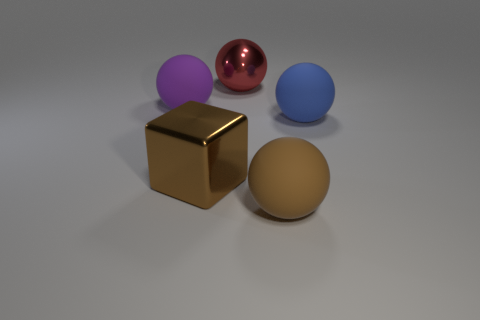Is the object that is left of the brown metallic cube made of the same material as the red sphere?
Ensure brevity in your answer.  No. What number of big matte objects are both behind the big brown metallic block and to the left of the blue ball?
Make the answer very short. 1. There is a shiny thing behind the matte object behind the large blue matte ball; how big is it?
Provide a succinct answer. Large. Is there any other thing that has the same material as the large cube?
Ensure brevity in your answer.  Yes. Are there more small green things than large blue objects?
Ensure brevity in your answer.  No. There is a metal thing to the left of the large shiny ball; is its color the same as the matte sphere to the left of the metal ball?
Keep it short and to the point. No. There is a rubber object on the right side of the large brown rubber ball; are there any blocks in front of it?
Keep it short and to the point. Yes. Is the number of purple rubber things that are to the right of the red thing less than the number of large brown balls behind the big blue matte sphere?
Offer a terse response. No. Are the large sphere on the left side of the shiny cube and the large ball that is in front of the big blue object made of the same material?
Make the answer very short. Yes. What number of large things are either yellow metallic blocks or cubes?
Make the answer very short. 1. 